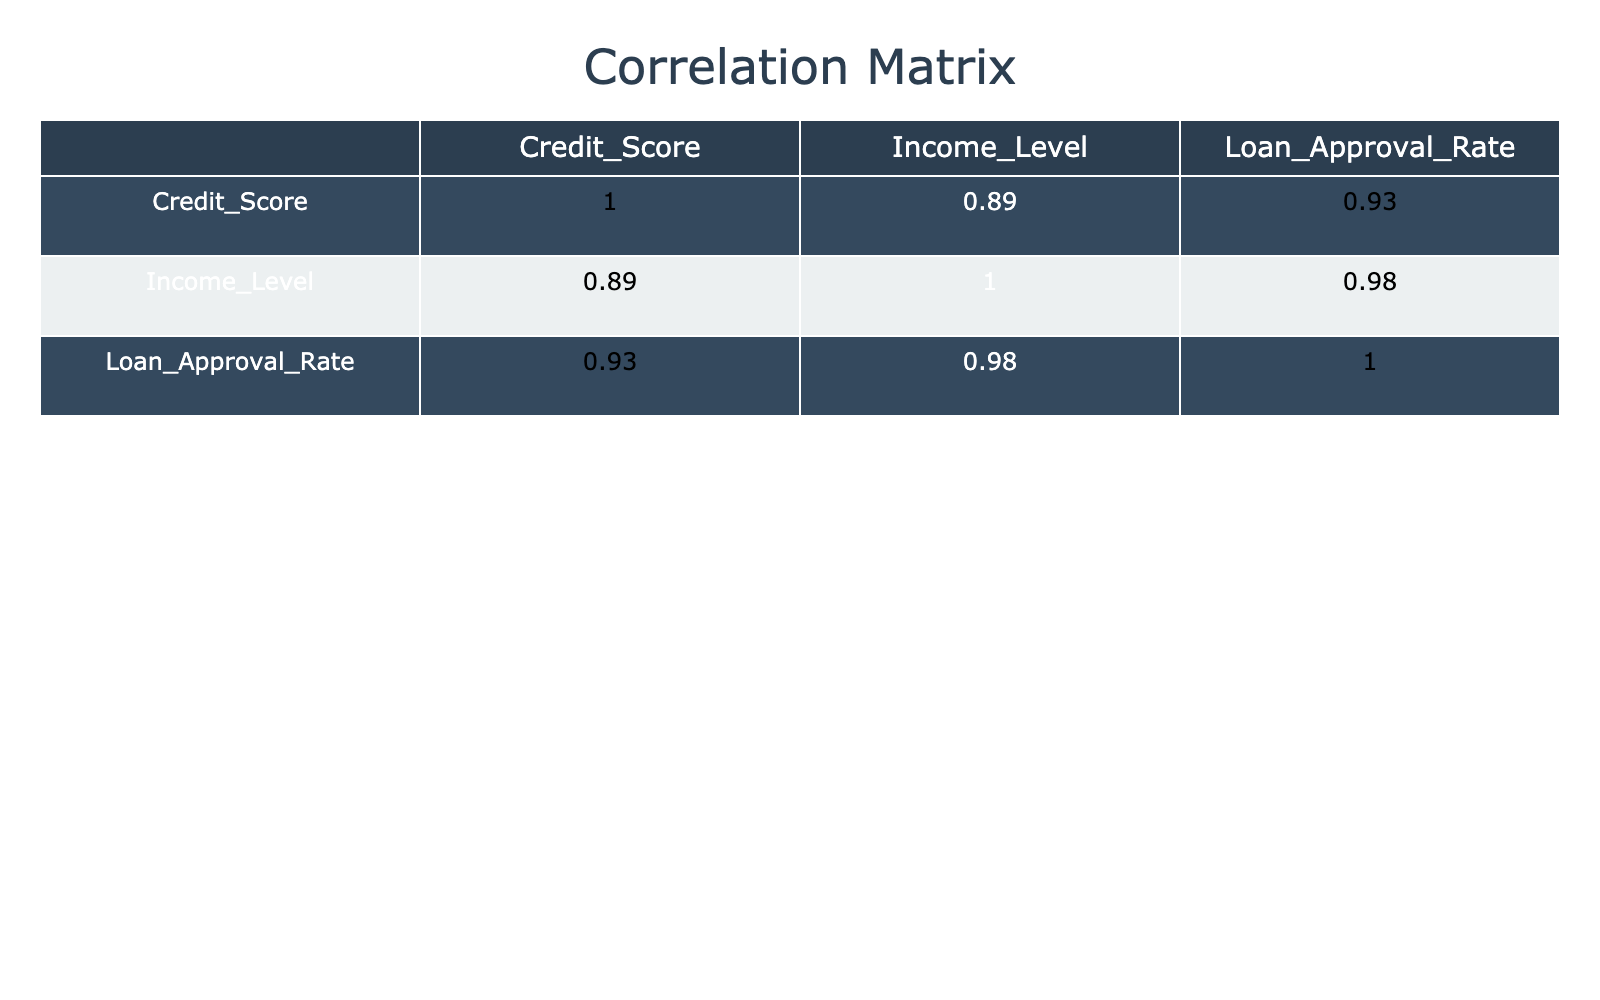What is the loan approval rate for a credit score of 800? From the table, we can see that the loan approval rate corresponding to a credit score of 800 is listed. It states 90.
Answer: 90 What is the loan approval rate for someone with an income level of 25000? The table indicates that for an income level of 25000, the loan approval rate is 5.
Answer: 5 Is it true that a credit score of 600 has a higher loan approval rate than an income level of 50000? The loan approval rate for a credit score of 600 is 45, while the income level of 50000 also has a loan approval rate of 45. Since they're equal, the statement is not true.
Answer: No What is the difference in loan approval rates between a credit score of 500 and a credit score of 700? The loan approval rate for a credit score of 500 is 25, and for 700 it is 70. The difference is calculated as 70 - 25 = 45.
Answer: 45 What is the average loan approval rate for income levels below 50000? The income levels below 50000 are 25000 (5), 30000 (10), 32000 (20), and 40000 (25). We sum these approval rates: 5 + 10 + 20 + 25 = 60. There are 4 data points, so the average is 60 / 4 = 15.
Answer: 15 Which income level has the highest loan approval rate? By looking at the table, we can compare the loan approval rates across all income levels. It shows that the income level 75000 has the highest rate of 90.
Answer: 75000 Is the loan approval rate for a credit score of 650 greater than the average approval rate for all income levels? First, we find the average approval rate by summing all rates: 5 + 10 + 25 + 45 + 70 + 90 + 68 + 40 + 20 + 85 =  418. Dividing by 10 gives an average of 41.8. The rate for 650 is 40, which is not greater.
Answer: No What is the median loan approval rate for credit scores listed? The loan approval rates in order: 5, 10, 20, 25, 40, 45, 68, 70, 85, 90. Since there are 10 data points, the median is the average of the 5th (40) and 6th (45) values: (40 + 45)/2 = 42.5.
Answer: 42.5 How does the loan approval rate change when the credit score increases from 580 to 800? Checking the approval rates for those credit scores, 580 has a rate of 20, and 800 has a rate of 90. The change can be calculated as 90 - 20 = 70, indicating a significant increase.
Answer: 70 